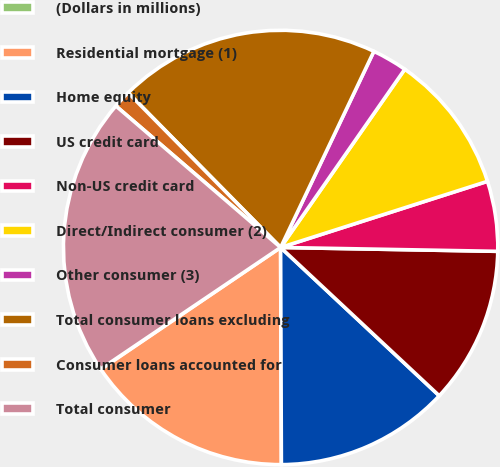Convert chart to OTSL. <chart><loc_0><loc_0><loc_500><loc_500><pie_chart><fcel>(Dollars in millions)<fcel>Residential mortgage (1)<fcel>Home equity<fcel>US credit card<fcel>Non-US credit card<fcel>Direct/Indirect consumer (2)<fcel>Other consumer (3)<fcel>Total consumer loans excluding<fcel>Consumer loans accounted for<fcel>Total consumer<nl><fcel>0.03%<fcel>15.57%<fcel>12.98%<fcel>11.68%<fcel>5.21%<fcel>10.39%<fcel>2.62%<fcel>19.45%<fcel>1.32%<fcel>20.75%<nl></chart> 